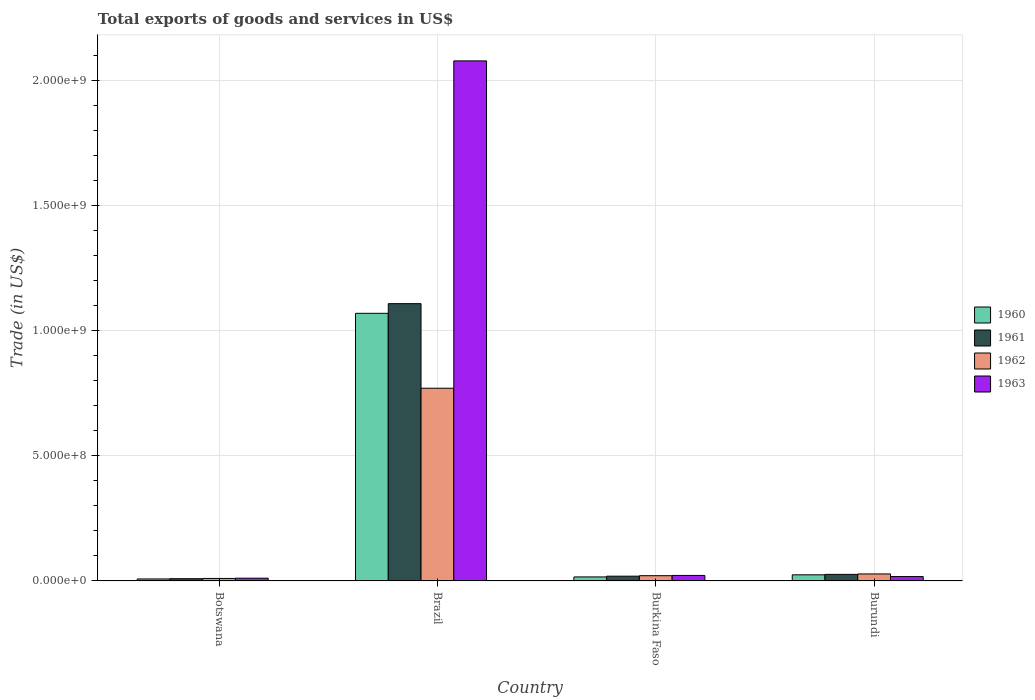How many different coloured bars are there?
Provide a succinct answer. 4. How many groups of bars are there?
Provide a short and direct response. 4. How many bars are there on the 4th tick from the left?
Make the answer very short. 4. How many bars are there on the 2nd tick from the right?
Your answer should be compact. 4. What is the label of the 2nd group of bars from the left?
Offer a terse response. Brazil. What is the total exports of goods and services in 1963 in Burundi?
Your answer should be compact. 1.75e+07. Across all countries, what is the maximum total exports of goods and services in 1960?
Offer a very short reply. 1.07e+09. Across all countries, what is the minimum total exports of goods and services in 1963?
Your answer should be compact. 1.10e+07. In which country was the total exports of goods and services in 1961 maximum?
Your answer should be compact. Brazil. In which country was the total exports of goods and services in 1960 minimum?
Make the answer very short. Botswana. What is the total total exports of goods and services in 1963 in the graph?
Provide a succinct answer. 2.13e+09. What is the difference between the total exports of goods and services in 1960 in Botswana and that in Burundi?
Offer a very short reply. -1.65e+07. What is the difference between the total exports of goods and services in 1961 in Botswana and the total exports of goods and services in 1963 in Burkina Faso?
Make the answer very short. -1.30e+07. What is the average total exports of goods and services in 1963 per country?
Your response must be concise. 5.33e+08. What is the difference between the total exports of goods and services of/in 1960 and total exports of goods and services of/in 1962 in Botswana?
Provide a short and direct response. -1.96e+06. What is the ratio of the total exports of goods and services in 1960 in Burkina Faso to that in Burundi?
Your answer should be very brief. 0.66. Is the total exports of goods and services in 1962 in Botswana less than that in Brazil?
Your answer should be compact. Yes. What is the difference between the highest and the second highest total exports of goods and services in 1960?
Keep it short and to the point. 1.05e+09. What is the difference between the highest and the lowest total exports of goods and services in 1961?
Offer a very short reply. 1.10e+09. In how many countries, is the total exports of goods and services in 1961 greater than the average total exports of goods and services in 1961 taken over all countries?
Keep it short and to the point. 1. Is it the case that in every country, the sum of the total exports of goods and services in 1962 and total exports of goods and services in 1963 is greater than the sum of total exports of goods and services in 1960 and total exports of goods and services in 1961?
Make the answer very short. No. What does the 1st bar from the left in Brazil represents?
Make the answer very short. 1960. What does the 2nd bar from the right in Burundi represents?
Make the answer very short. 1962. How many bars are there?
Your answer should be compact. 16. What is the difference between two consecutive major ticks on the Y-axis?
Your answer should be compact. 5.00e+08. How many legend labels are there?
Your answer should be compact. 4. How are the legend labels stacked?
Keep it short and to the point. Vertical. What is the title of the graph?
Provide a short and direct response. Total exports of goods and services in US$. What is the label or title of the Y-axis?
Keep it short and to the point. Trade (in US$). What is the Trade (in US$) of 1960 in Botswana?
Your response must be concise. 7.99e+06. What is the Trade (in US$) in 1961 in Botswana?
Give a very brief answer. 8.95e+06. What is the Trade (in US$) of 1962 in Botswana?
Ensure brevity in your answer.  9.95e+06. What is the Trade (in US$) in 1963 in Botswana?
Your answer should be very brief. 1.10e+07. What is the Trade (in US$) of 1960 in Brazil?
Your response must be concise. 1.07e+09. What is the Trade (in US$) of 1961 in Brazil?
Offer a terse response. 1.11e+09. What is the Trade (in US$) of 1962 in Brazil?
Offer a very short reply. 7.71e+08. What is the Trade (in US$) of 1963 in Brazil?
Offer a terse response. 2.08e+09. What is the Trade (in US$) of 1960 in Burkina Faso?
Your answer should be compact. 1.61e+07. What is the Trade (in US$) in 1961 in Burkina Faso?
Give a very brief answer. 1.90e+07. What is the Trade (in US$) of 1962 in Burkina Faso?
Your response must be concise. 2.10e+07. What is the Trade (in US$) in 1963 in Burkina Faso?
Your answer should be compact. 2.20e+07. What is the Trade (in US$) of 1960 in Burundi?
Keep it short and to the point. 2.45e+07. What is the Trade (in US$) of 1961 in Burundi?
Make the answer very short. 2.62e+07. What is the Trade (in US$) in 1962 in Burundi?
Your answer should be very brief. 2.80e+07. What is the Trade (in US$) of 1963 in Burundi?
Your answer should be very brief. 1.75e+07. Across all countries, what is the maximum Trade (in US$) of 1960?
Your answer should be very brief. 1.07e+09. Across all countries, what is the maximum Trade (in US$) in 1961?
Your answer should be very brief. 1.11e+09. Across all countries, what is the maximum Trade (in US$) in 1962?
Offer a very short reply. 7.71e+08. Across all countries, what is the maximum Trade (in US$) of 1963?
Provide a short and direct response. 2.08e+09. Across all countries, what is the minimum Trade (in US$) in 1960?
Provide a short and direct response. 7.99e+06. Across all countries, what is the minimum Trade (in US$) of 1961?
Provide a short and direct response. 8.95e+06. Across all countries, what is the minimum Trade (in US$) in 1962?
Offer a very short reply. 9.95e+06. Across all countries, what is the minimum Trade (in US$) of 1963?
Give a very brief answer. 1.10e+07. What is the total Trade (in US$) of 1960 in the graph?
Provide a succinct answer. 1.12e+09. What is the total Trade (in US$) of 1961 in the graph?
Your answer should be compact. 1.16e+09. What is the total Trade (in US$) of 1962 in the graph?
Offer a terse response. 8.30e+08. What is the total Trade (in US$) of 1963 in the graph?
Keep it short and to the point. 2.13e+09. What is the difference between the Trade (in US$) of 1960 in Botswana and that in Brazil?
Make the answer very short. -1.06e+09. What is the difference between the Trade (in US$) of 1961 in Botswana and that in Brazil?
Offer a terse response. -1.10e+09. What is the difference between the Trade (in US$) in 1962 in Botswana and that in Brazil?
Provide a short and direct response. -7.61e+08. What is the difference between the Trade (in US$) of 1963 in Botswana and that in Brazil?
Give a very brief answer. -2.07e+09. What is the difference between the Trade (in US$) of 1960 in Botswana and that in Burkina Faso?
Your response must be concise. -8.08e+06. What is the difference between the Trade (in US$) of 1961 in Botswana and that in Burkina Faso?
Ensure brevity in your answer.  -1.01e+07. What is the difference between the Trade (in US$) of 1962 in Botswana and that in Burkina Faso?
Your answer should be compact. -1.10e+07. What is the difference between the Trade (in US$) of 1963 in Botswana and that in Burkina Faso?
Ensure brevity in your answer.  -1.09e+07. What is the difference between the Trade (in US$) in 1960 in Botswana and that in Burundi?
Give a very brief answer. -1.65e+07. What is the difference between the Trade (in US$) of 1961 in Botswana and that in Burundi?
Your answer should be very brief. -1.73e+07. What is the difference between the Trade (in US$) in 1962 in Botswana and that in Burundi?
Ensure brevity in your answer.  -1.80e+07. What is the difference between the Trade (in US$) of 1963 in Botswana and that in Burundi?
Offer a terse response. -6.46e+06. What is the difference between the Trade (in US$) in 1960 in Brazil and that in Burkina Faso?
Offer a very short reply. 1.05e+09. What is the difference between the Trade (in US$) in 1961 in Brazil and that in Burkina Faso?
Provide a succinct answer. 1.09e+09. What is the difference between the Trade (in US$) in 1962 in Brazil and that in Burkina Faso?
Offer a terse response. 7.50e+08. What is the difference between the Trade (in US$) of 1963 in Brazil and that in Burkina Faso?
Your answer should be very brief. 2.06e+09. What is the difference between the Trade (in US$) of 1960 in Brazil and that in Burundi?
Give a very brief answer. 1.05e+09. What is the difference between the Trade (in US$) in 1961 in Brazil and that in Burundi?
Keep it short and to the point. 1.08e+09. What is the difference between the Trade (in US$) of 1962 in Brazil and that in Burundi?
Provide a short and direct response. 7.43e+08. What is the difference between the Trade (in US$) of 1963 in Brazil and that in Burundi?
Provide a short and direct response. 2.06e+09. What is the difference between the Trade (in US$) of 1960 in Burkina Faso and that in Burundi?
Provide a succinct answer. -8.43e+06. What is the difference between the Trade (in US$) of 1961 in Burkina Faso and that in Burundi?
Make the answer very short. -7.24e+06. What is the difference between the Trade (in US$) in 1962 in Burkina Faso and that in Burundi?
Provide a short and direct response. -7.00e+06. What is the difference between the Trade (in US$) of 1963 in Burkina Faso and that in Burundi?
Keep it short and to the point. 4.49e+06. What is the difference between the Trade (in US$) of 1960 in Botswana and the Trade (in US$) of 1961 in Brazil?
Ensure brevity in your answer.  -1.10e+09. What is the difference between the Trade (in US$) of 1960 in Botswana and the Trade (in US$) of 1962 in Brazil?
Your answer should be compact. -7.63e+08. What is the difference between the Trade (in US$) in 1960 in Botswana and the Trade (in US$) in 1963 in Brazil?
Provide a succinct answer. -2.07e+09. What is the difference between the Trade (in US$) in 1961 in Botswana and the Trade (in US$) in 1962 in Brazil?
Provide a succinct answer. -7.62e+08. What is the difference between the Trade (in US$) of 1961 in Botswana and the Trade (in US$) of 1963 in Brazil?
Provide a short and direct response. -2.07e+09. What is the difference between the Trade (in US$) in 1962 in Botswana and the Trade (in US$) in 1963 in Brazil?
Give a very brief answer. -2.07e+09. What is the difference between the Trade (in US$) in 1960 in Botswana and the Trade (in US$) in 1961 in Burkina Faso?
Give a very brief answer. -1.10e+07. What is the difference between the Trade (in US$) of 1960 in Botswana and the Trade (in US$) of 1962 in Burkina Faso?
Your answer should be compact. -1.30e+07. What is the difference between the Trade (in US$) of 1960 in Botswana and the Trade (in US$) of 1963 in Burkina Faso?
Offer a very short reply. -1.40e+07. What is the difference between the Trade (in US$) of 1961 in Botswana and the Trade (in US$) of 1962 in Burkina Faso?
Offer a very short reply. -1.20e+07. What is the difference between the Trade (in US$) of 1961 in Botswana and the Trade (in US$) of 1963 in Burkina Faso?
Offer a terse response. -1.30e+07. What is the difference between the Trade (in US$) of 1962 in Botswana and the Trade (in US$) of 1963 in Burkina Faso?
Your answer should be compact. -1.20e+07. What is the difference between the Trade (in US$) of 1960 in Botswana and the Trade (in US$) of 1961 in Burundi?
Keep it short and to the point. -1.83e+07. What is the difference between the Trade (in US$) of 1960 in Botswana and the Trade (in US$) of 1962 in Burundi?
Your answer should be very brief. -2.00e+07. What is the difference between the Trade (in US$) in 1960 in Botswana and the Trade (in US$) in 1963 in Burundi?
Provide a succinct answer. -9.51e+06. What is the difference between the Trade (in US$) in 1961 in Botswana and the Trade (in US$) in 1962 in Burundi?
Make the answer very short. -1.90e+07. What is the difference between the Trade (in US$) of 1961 in Botswana and the Trade (in US$) of 1963 in Burundi?
Provide a short and direct response. -8.55e+06. What is the difference between the Trade (in US$) in 1962 in Botswana and the Trade (in US$) in 1963 in Burundi?
Offer a very short reply. -7.55e+06. What is the difference between the Trade (in US$) of 1960 in Brazil and the Trade (in US$) of 1961 in Burkina Faso?
Ensure brevity in your answer.  1.05e+09. What is the difference between the Trade (in US$) of 1960 in Brazil and the Trade (in US$) of 1962 in Burkina Faso?
Your answer should be very brief. 1.05e+09. What is the difference between the Trade (in US$) of 1960 in Brazil and the Trade (in US$) of 1963 in Burkina Faso?
Offer a terse response. 1.05e+09. What is the difference between the Trade (in US$) of 1961 in Brazil and the Trade (in US$) of 1962 in Burkina Faso?
Keep it short and to the point. 1.09e+09. What is the difference between the Trade (in US$) of 1961 in Brazil and the Trade (in US$) of 1963 in Burkina Faso?
Your answer should be compact. 1.09e+09. What is the difference between the Trade (in US$) in 1962 in Brazil and the Trade (in US$) in 1963 in Burkina Faso?
Your answer should be compact. 7.49e+08. What is the difference between the Trade (in US$) in 1960 in Brazil and the Trade (in US$) in 1961 in Burundi?
Your answer should be very brief. 1.04e+09. What is the difference between the Trade (in US$) of 1960 in Brazil and the Trade (in US$) of 1962 in Burundi?
Provide a short and direct response. 1.04e+09. What is the difference between the Trade (in US$) of 1960 in Brazil and the Trade (in US$) of 1963 in Burundi?
Your answer should be compact. 1.05e+09. What is the difference between the Trade (in US$) of 1961 in Brazil and the Trade (in US$) of 1962 in Burundi?
Keep it short and to the point. 1.08e+09. What is the difference between the Trade (in US$) of 1961 in Brazil and the Trade (in US$) of 1963 in Burundi?
Your answer should be compact. 1.09e+09. What is the difference between the Trade (in US$) of 1962 in Brazil and the Trade (in US$) of 1963 in Burundi?
Give a very brief answer. 7.53e+08. What is the difference between the Trade (in US$) of 1960 in Burkina Faso and the Trade (in US$) of 1961 in Burundi?
Your response must be concise. -1.02e+07. What is the difference between the Trade (in US$) of 1960 in Burkina Faso and the Trade (in US$) of 1962 in Burundi?
Make the answer very short. -1.19e+07. What is the difference between the Trade (in US$) of 1960 in Burkina Faso and the Trade (in US$) of 1963 in Burundi?
Provide a succinct answer. -1.43e+06. What is the difference between the Trade (in US$) in 1961 in Burkina Faso and the Trade (in US$) in 1962 in Burundi?
Ensure brevity in your answer.  -8.99e+06. What is the difference between the Trade (in US$) of 1961 in Burkina Faso and the Trade (in US$) of 1963 in Burundi?
Your response must be concise. 1.51e+06. What is the difference between the Trade (in US$) of 1962 in Burkina Faso and the Trade (in US$) of 1963 in Burundi?
Ensure brevity in your answer.  3.50e+06. What is the average Trade (in US$) in 1960 per country?
Your answer should be very brief. 2.80e+08. What is the average Trade (in US$) of 1961 per country?
Offer a terse response. 2.91e+08. What is the average Trade (in US$) in 1962 per country?
Offer a terse response. 2.07e+08. What is the average Trade (in US$) of 1963 per country?
Your answer should be very brief. 5.33e+08. What is the difference between the Trade (in US$) in 1960 and Trade (in US$) in 1961 in Botswana?
Your response must be concise. -9.64e+05. What is the difference between the Trade (in US$) in 1960 and Trade (in US$) in 1962 in Botswana?
Ensure brevity in your answer.  -1.96e+06. What is the difference between the Trade (in US$) in 1960 and Trade (in US$) in 1963 in Botswana?
Make the answer very short. -3.05e+06. What is the difference between the Trade (in US$) in 1961 and Trade (in US$) in 1962 in Botswana?
Ensure brevity in your answer.  -9.99e+05. What is the difference between the Trade (in US$) in 1961 and Trade (in US$) in 1963 in Botswana?
Your response must be concise. -2.09e+06. What is the difference between the Trade (in US$) of 1962 and Trade (in US$) of 1963 in Botswana?
Keep it short and to the point. -1.09e+06. What is the difference between the Trade (in US$) in 1960 and Trade (in US$) in 1961 in Brazil?
Your answer should be very brief. -3.86e+07. What is the difference between the Trade (in US$) of 1960 and Trade (in US$) of 1962 in Brazil?
Offer a very short reply. 3.00e+08. What is the difference between the Trade (in US$) in 1960 and Trade (in US$) in 1963 in Brazil?
Offer a terse response. -1.01e+09. What is the difference between the Trade (in US$) of 1961 and Trade (in US$) of 1962 in Brazil?
Provide a succinct answer. 3.38e+08. What is the difference between the Trade (in US$) of 1961 and Trade (in US$) of 1963 in Brazil?
Provide a short and direct response. -9.71e+08. What is the difference between the Trade (in US$) of 1962 and Trade (in US$) of 1963 in Brazil?
Provide a succinct answer. -1.31e+09. What is the difference between the Trade (in US$) in 1960 and Trade (in US$) in 1961 in Burkina Faso?
Make the answer very short. -2.95e+06. What is the difference between the Trade (in US$) of 1960 and Trade (in US$) of 1962 in Burkina Faso?
Make the answer very short. -4.93e+06. What is the difference between the Trade (in US$) in 1960 and Trade (in US$) in 1963 in Burkina Faso?
Offer a very short reply. -5.92e+06. What is the difference between the Trade (in US$) in 1961 and Trade (in US$) in 1962 in Burkina Faso?
Provide a short and direct response. -1.98e+06. What is the difference between the Trade (in US$) of 1961 and Trade (in US$) of 1963 in Burkina Faso?
Offer a terse response. -2.97e+06. What is the difference between the Trade (in US$) of 1962 and Trade (in US$) of 1963 in Burkina Faso?
Keep it short and to the point. -9.88e+05. What is the difference between the Trade (in US$) of 1960 and Trade (in US$) of 1961 in Burundi?
Keep it short and to the point. -1.75e+06. What is the difference between the Trade (in US$) in 1960 and Trade (in US$) in 1962 in Burundi?
Give a very brief answer. -3.50e+06. What is the difference between the Trade (in US$) in 1960 and Trade (in US$) in 1963 in Burundi?
Your response must be concise. 7.00e+06. What is the difference between the Trade (in US$) in 1961 and Trade (in US$) in 1962 in Burundi?
Your answer should be compact. -1.75e+06. What is the difference between the Trade (in US$) in 1961 and Trade (in US$) in 1963 in Burundi?
Keep it short and to the point. 8.75e+06. What is the difference between the Trade (in US$) of 1962 and Trade (in US$) of 1963 in Burundi?
Offer a terse response. 1.05e+07. What is the ratio of the Trade (in US$) of 1960 in Botswana to that in Brazil?
Provide a short and direct response. 0.01. What is the ratio of the Trade (in US$) in 1961 in Botswana to that in Brazil?
Your response must be concise. 0.01. What is the ratio of the Trade (in US$) in 1962 in Botswana to that in Brazil?
Your answer should be compact. 0.01. What is the ratio of the Trade (in US$) in 1963 in Botswana to that in Brazil?
Your answer should be very brief. 0.01. What is the ratio of the Trade (in US$) in 1960 in Botswana to that in Burkina Faso?
Ensure brevity in your answer.  0.5. What is the ratio of the Trade (in US$) in 1961 in Botswana to that in Burkina Faso?
Provide a succinct answer. 0.47. What is the ratio of the Trade (in US$) in 1962 in Botswana to that in Burkina Faso?
Your answer should be compact. 0.47. What is the ratio of the Trade (in US$) in 1963 in Botswana to that in Burkina Faso?
Your answer should be compact. 0.5. What is the ratio of the Trade (in US$) of 1960 in Botswana to that in Burundi?
Keep it short and to the point. 0.33. What is the ratio of the Trade (in US$) of 1961 in Botswana to that in Burundi?
Your answer should be very brief. 0.34. What is the ratio of the Trade (in US$) of 1962 in Botswana to that in Burundi?
Offer a terse response. 0.36. What is the ratio of the Trade (in US$) of 1963 in Botswana to that in Burundi?
Make the answer very short. 0.63. What is the ratio of the Trade (in US$) of 1960 in Brazil to that in Burkina Faso?
Ensure brevity in your answer.  66.63. What is the ratio of the Trade (in US$) of 1961 in Brazil to that in Burkina Faso?
Your answer should be compact. 58.33. What is the ratio of the Trade (in US$) in 1962 in Brazil to that in Burkina Faso?
Make the answer very short. 36.71. What is the ratio of the Trade (in US$) in 1963 in Brazil to that in Burkina Faso?
Provide a short and direct response. 94.62. What is the ratio of the Trade (in US$) of 1960 in Brazil to that in Burundi?
Offer a terse response. 43.7. What is the ratio of the Trade (in US$) in 1961 in Brazil to that in Burundi?
Provide a succinct answer. 42.25. What is the ratio of the Trade (in US$) in 1962 in Brazil to that in Burundi?
Your response must be concise. 27.53. What is the ratio of the Trade (in US$) of 1963 in Brazil to that in Burundi?
Make the answer very short. 118.88. What is the ratio of the Trade (in US$) in 1960 in Burkina Faso to that in Burundi?
Offer a very short reply. 0.66. What is the ratio of the Trade (in US$) in 1961 in Burkina Faso to that in Burundi?
Provide a short and direct response. 0.72. What is the ratio of the Trade (in US$) in 1962 in Burkina Faso to that in Burundi?
Ensure brevity in your answer.  0.75. What is the ratio of the Trade (in US$) in 1963 in Burkina Faso to that in Burundi?
Your answer should be compact. 1.26. What is the difference between the highest and the second highest Trade (in US$) of 1960?
Provide a short and direct response. 1.05e+09. What is the difference between the highest and the second highest Trade (in US$) in 1961?
Ensure brevity in your answer.  1.08e+09. What is the difference between the highest and the second highest Trade (in US$) in 1962?
Provide a short and direct response. 7.43e+08. What is the difference between the highest and the second highest Trade (in US$) in 1963?
Provide a short and direct response. 2.06e+09. What is the difference between the highest and the lowest Trade (in US$) of 1960?
Make the answer very short. 1.06e+09. What is the difference between the highest and the lowest Trade (in US$) of 1961?
Your answer should be very brief. 1.10e+09. What is the difference between the highest and the lowest Trade (in US$) of 1962?
Ensure brevity in your answer.  7.61e+08. What is the difference between the highest and the lowest Trade (in US$) in 1963?
Provide a short and direct response. 2.07e+09. 